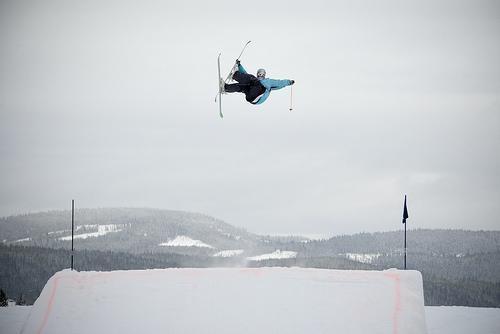How many people are in this picture?
Give a very brief answer. 1. 